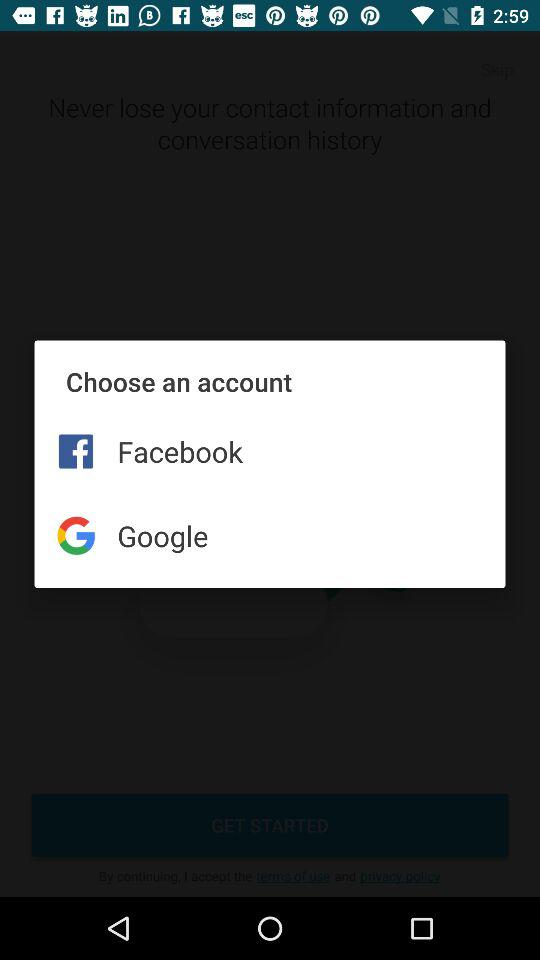How many accounts are available to choose from?
Answer the question using a single word or phrase. 2 